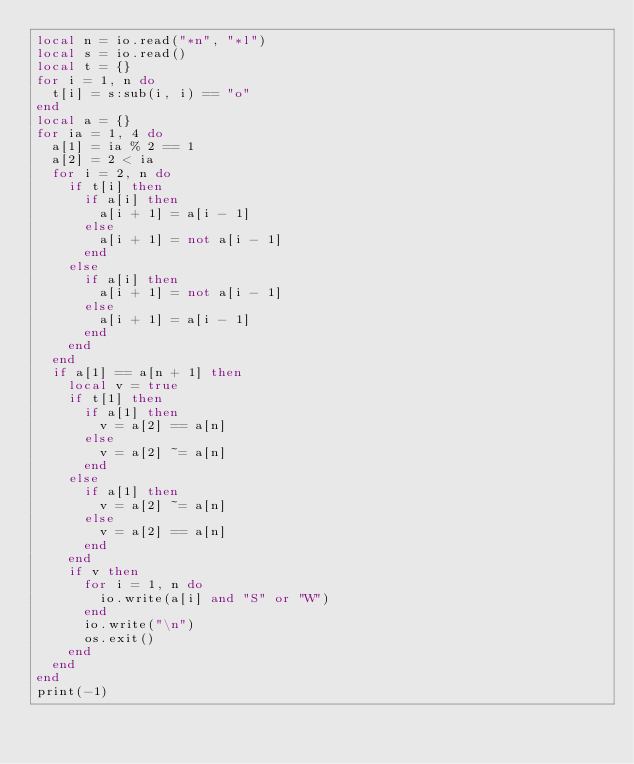Convert code to text. <code><loc_0><loc_0><loc_500><loc_500><_Lua_>local n = io.read("*n", "*l")
local s = io.read()
local t = {}
for i = 1, n do
  t[i] = s:sub(i, i) == "o"
end
local a = {}
for ia = 1, 4 do
  a[1] = ia % 2 == 1
  a[2] = 2 < ia
  for i = 2, n do
    if t[i] then
      if a[i] then
        a[i + 1] = a[i - 1]
      else
        a[i + 1] = not a[i - 1]
      end
    else
      if a[i] then
        a[i + 1] = not a[i - 1]
      else
        a[i + 1] = a[i - 1]
      end
    end
  end
  if a[1] == a[n + 1] then
    local v = true
    if t[1] then
      if a[1] then
        v = a[2] == a[n]
      else
        v = a[2] ~= a[n]
      end
    else
      if a[1] then
        v = a[2] ~= a[n]
      else
        v = a[2] == a[n]
      end
    end
    if v then
      for i = 1, n do
        io.write(a[i] and "S" or "W")
      end
      io.write("\n")
      os.exit()
    end
  end
end
print(-1)
</code> 